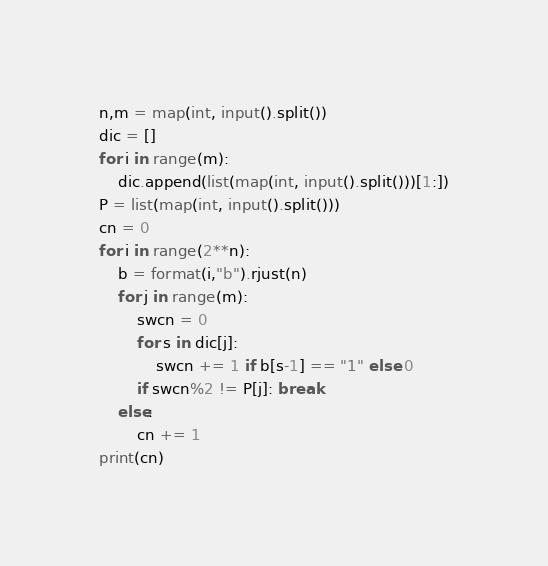Convert code to text. <code><loc_0><loc_0><loc_500><loc_500><_Python_>n,m = map(int, input().split())
dic = []
for i in range(m):
    dic.append(list(map(int, input().split()))[1:])
P = list(map(int, input().split()))
cn = 0
for i in range(2**n):
    b = format(i,"b").rjust(n)
    for j in range(m):
        swcn = 0
        for s in dic[j]:
            swcn += 1 if b[s-1] == "1" else 0
        if swcn%2 != P[j]: break
    else:
        cn += 1
print(cn)</code> 